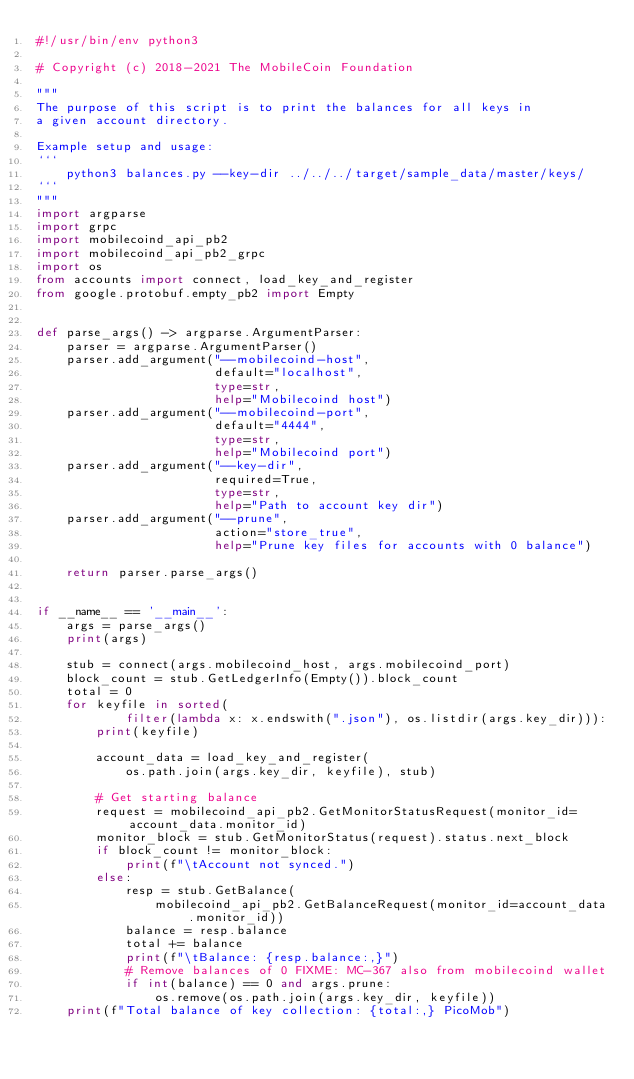<code> <loc_0><loc_0><loc_500><loc_500><_Python_>#!/usr/bin/env python3

# Copyright (c) 2018-2021 The MobileCoin Foundation

"""
The purpose of this script is to print the balances for all keys in
a given account directory.

Example setup and usage:
```
    python3 balances.py --key-dir ../../../target/sample_data/master/keys/
```
"""
import argparse
import grpc
import mobilecoind_api_pb2
import mobilecoind_api_pb2_grpc
import os
from accounts import connect, load_key_and_register
from google.protobuf.empty_pb2 import Empty


def parse_args() -> argparse.ArgumentParser:
    parser = argparse.ArgumentParser()
    parser.add_argument("--mobilecoind-host",
                        default="localhost",
                        type=str,
                        help="Mobilecoind host")
    parser.add_argument("--mobilecoind-port",
                        default="4444",
                        type=str,
                        help="Mobilecoind port")
    parser.add_argument("--key-dir",
                        required=True,
                        type=str,
                        help="Path to account key dir")
    parser.add_argument("--prune",
                        action="store_true",
                        help="Prune key files for accounts with 0 balance")

    return parser.parse_args()


if __name__ == '__main__':
    args = parse_args()
    print(args)

    stub = connect(args.mobilecoind_host, args.mobilecoind_port)
    block_count = stub.GetLedgerInfo(Empty()).block_count
    total = 0
    for keyfile in sorted(
            filter(lambda x: x.endswith(".json"), os.listdir(args.key_dir))):
        print(keyfile)

        account_data = load_key_and_register(
            os.path.join(args.key_dir, keyfile), stub)

        # Get starting balance
        request = mobilecoind_api_pb2.GetMonitorStatusRequest(monitor_id=account_data.monitor_id)
        monitor_block = stub.GetMonitorStatus(request).status.next_block
        if block_count != monitor_block:
            print(f"\tAccount not synced.")
        else:
            resp = stub.GetBalance(
                mobilecoind_api_pb2.GetBalanceRequest(monitor_id=account_data.monitor_id))
            balance = resp.balance
            total += balance
            print(f"\tBalance: {resp.balance:,}")
            # Remove balances of 0 FIXME: MC-367 also from mobilecoind wallet
            if int(balance) == 0 and args.prune:
                os.remove(os.path.join(args.key_dir, keyfile))
    print(f"Total balance of key collection: {total:,} PicoMob")
</code> 